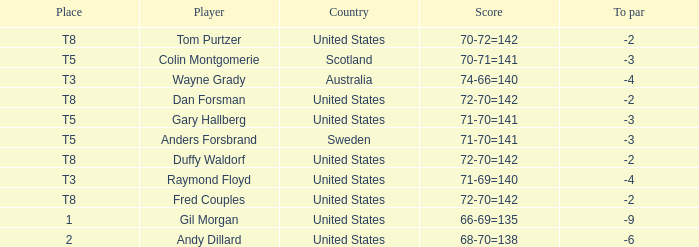What is the T8 Place Player? Fred Couples, Dan Forsman, Tom Purtzer, Duffy Waldorf. 